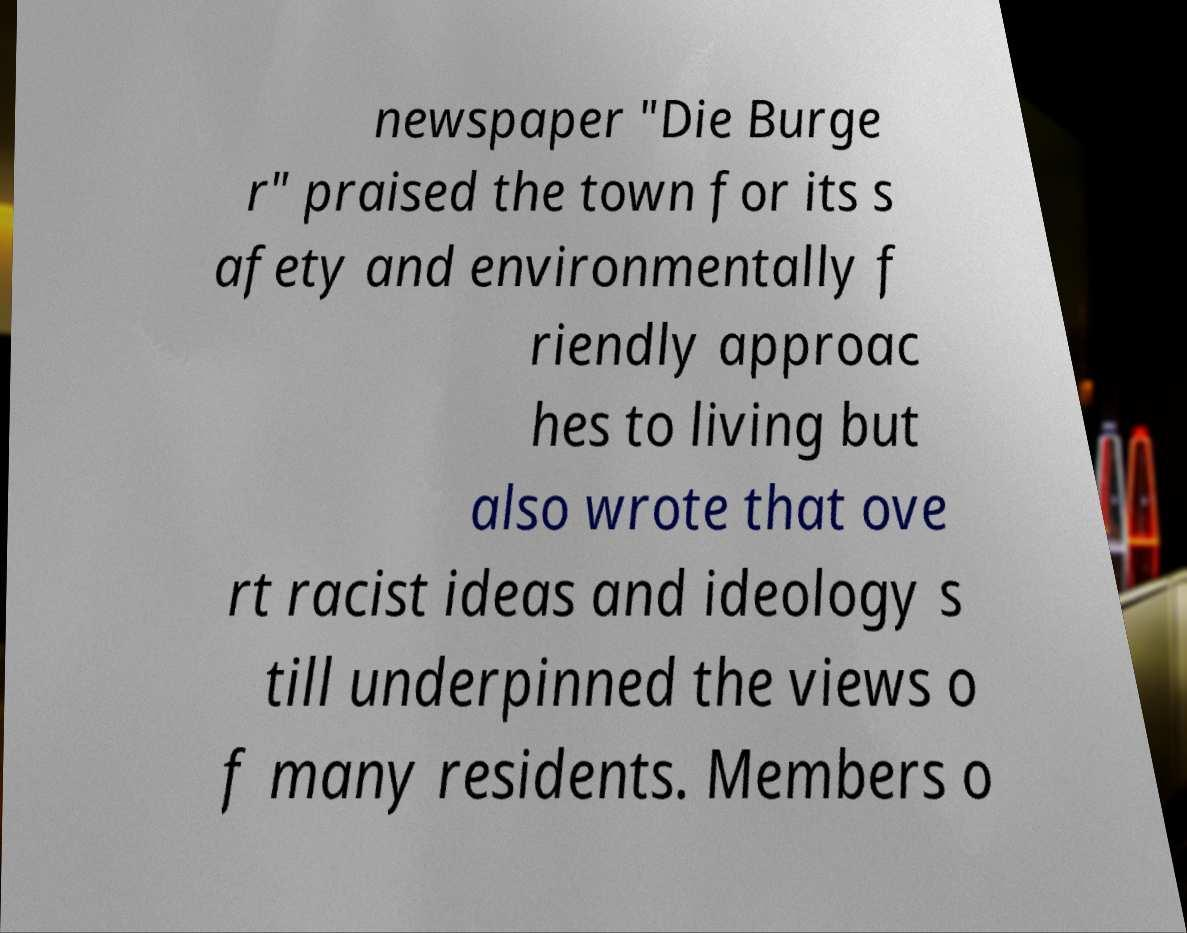There's text embedded in this image that I need extracted. Can you transcribe it verbatim? newspaper "Die Burge r" praised the town for its s afety and environmentally f riendly approac hes to living but also wrote that ove rt racist ideas and ideology s till underpinned the views o f many residents. Members o 